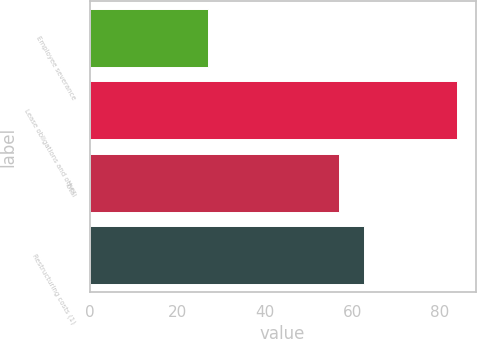Convert chart. <chart><loc_0><loc_0><loc_500><loc_500><bar_chart><fcel>Employee severance<fcel>Lease obligations and other<fcel>Total<fcel>Restructuring costs (1)<nl><fcel>27<fcel>84<fcel>57<fcel>62.7<nl></chart> 